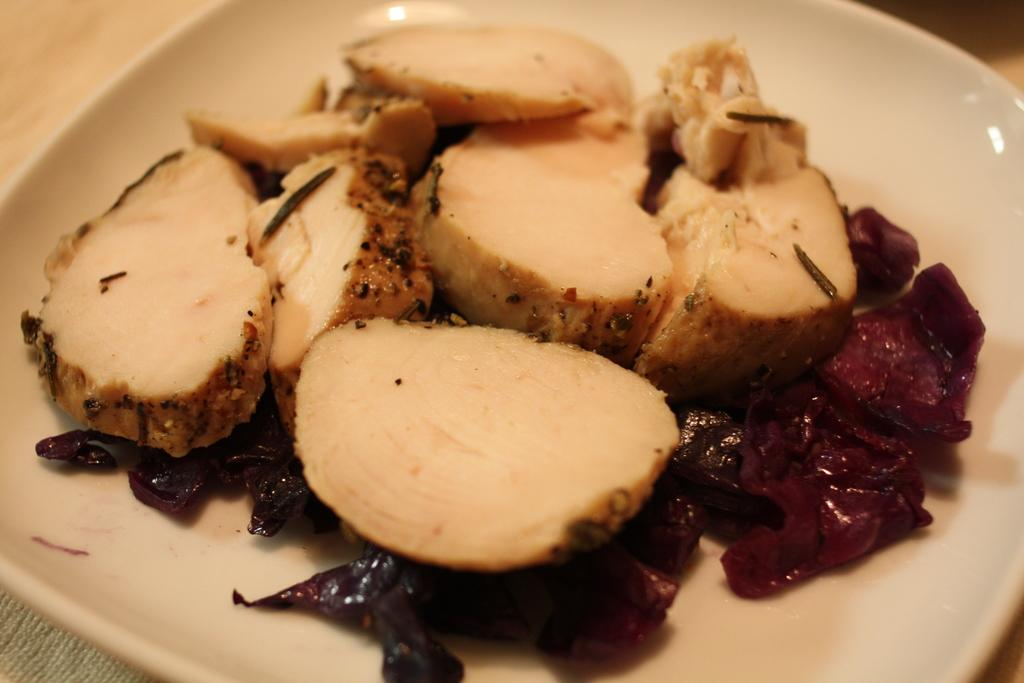What object can be seen in the image that is typically used for serving food? There is a plate in the image that is typically used for serving food. What is on the plate in the image? The plate contains food. What type of thread is used to sew the flag in the image? There is no flag present in the image, so it is not possible to determine what type of thread might be used to sew it. 